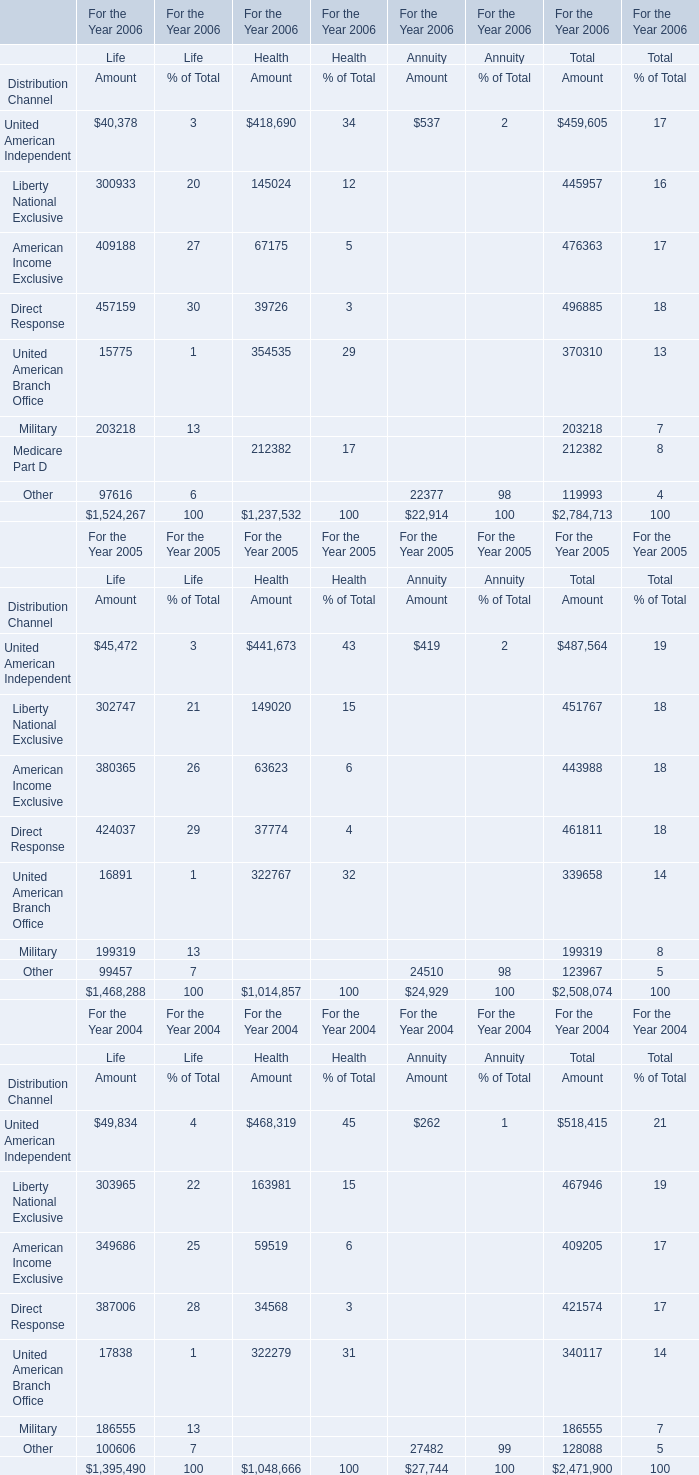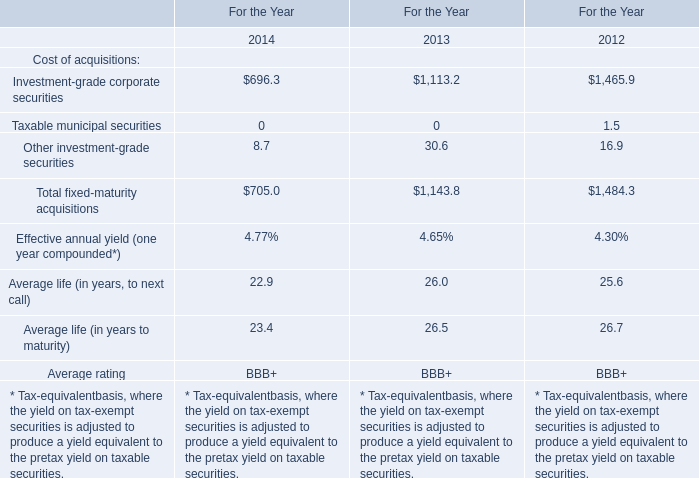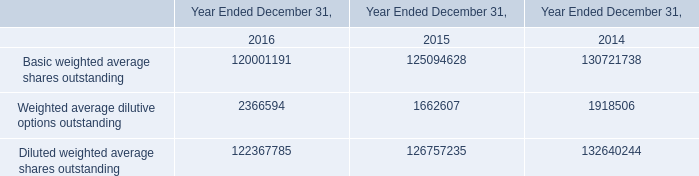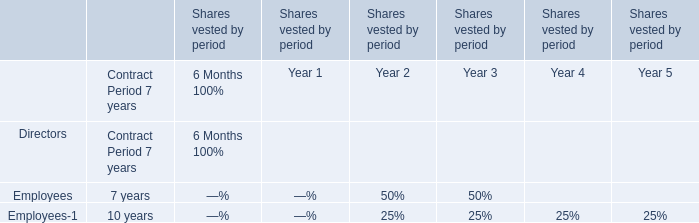What is the growing rate of United American Independent in the years with the least Life 
Computations: ((487564 - 518415) / 518415)
Answer: -0.05951. 